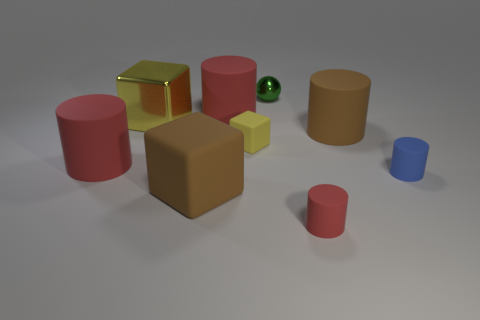There is a thing that is both right of the small yellow matte object and behind the brown matte cylinder; how big is it?
Offer a terse response. Small. Are there more tiny shiny objects that are on the left side of the tiny green thing than red objects behind the small yellow object?
Provide a short and direct response. No. There is a matte cube that is the same color as the large shiny object; what size is it?
Your response must be concise. Small. What color is the small sphere?
Give a very brief answer. Green. There is a cube that is on the right side of the big metallic thing and behind the big matte cube; what is its color?
Provide a short and direct response. Yellow. What color is the matte cylinder that is to the left of the red cylinder behind the metallic thing that is on the left side of the small sphere?
Offer a very short reply. Red. What is the color of the cube that is the same size as the green ball?
Ensure brevity in your answer.  Yellow. The red thing that is on the left side of the big cube behind the large brown thing that is right of the green metal ball is what shape?
Offer a terse response. Cylinder. There is another object that is the same color as the big metal thing; what is its shape?
Your answer should be compact. Cube. What number of things are tiny red matte cylinders or things that are left of the small metallic object?
Your answer should be compact. 6. 